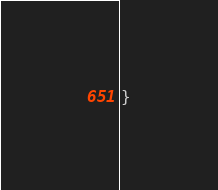Convert code to text. <code><loc_0><loc_0><loc_500><loc_500><_Java_>
}
</code> 